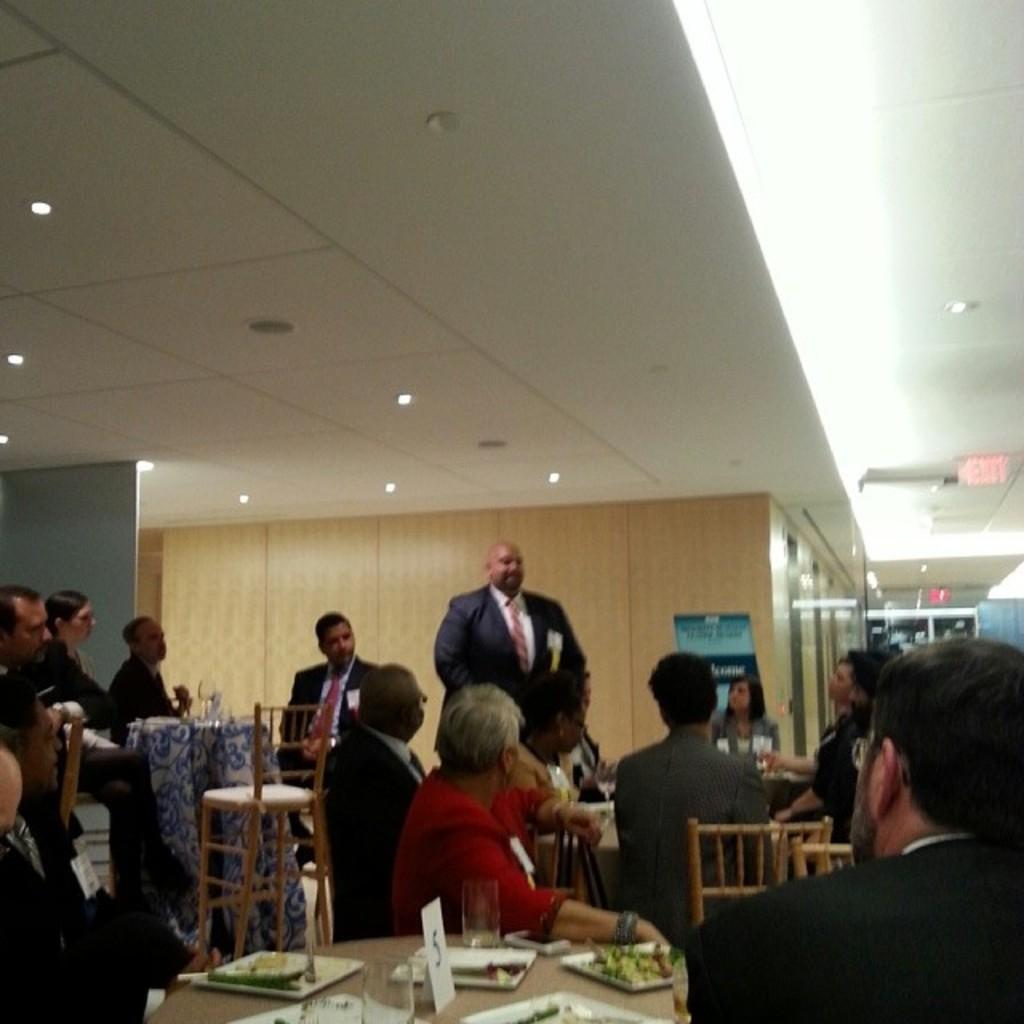What are the people in the image doing? The people in the image are sitting on chairs. Is there anyone standing in the image? Yes, there is a man standing in the image. Where is the man standing in relation to the people sitting on chairs? The man is standing among the people sitting on chairs. What type of discussion is taking place among the clouds in the image? There are no clouds present in the image, and therefore no discussion among them can be observed. Where is the faucet located in the image? There is no faucet present in the image. 